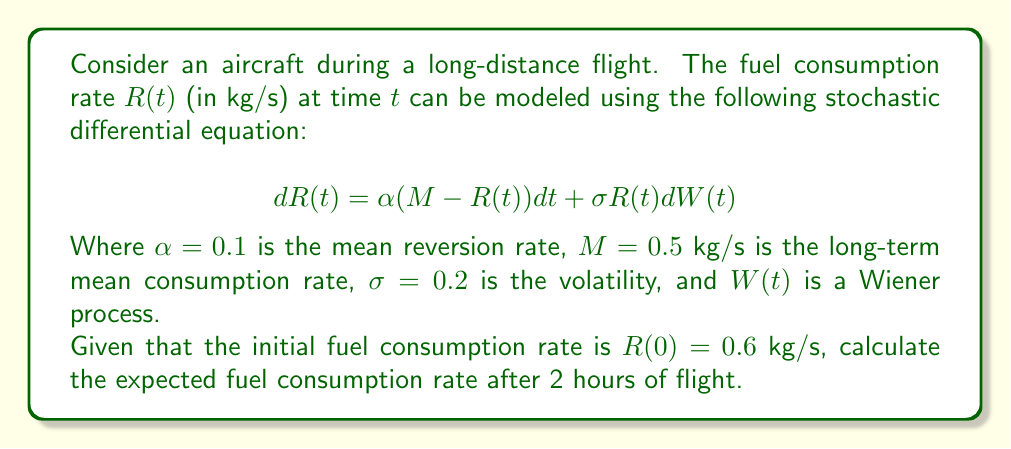Solve this math problem. To solve this problem, we need to understand the properties of the Ornstein-Uhlenbeck process, which is described by the given stochastic differential equation. The solution to this equation has the following properties:

1) The expected value of $R(t)$ is given by:

   $$E[R(t)] = M + (R(0) - M)e^{-\alpha t}$$

2) We are given:
   - $\alpha = 0.1$
   - $M = 0.5$ kg/s
   - $R(0) = 0.6$ kg/s
   - $t = 2$ hours = 7200 seconds

3) Let's substitute these values into the equation:

   $$E[R(7200)] = 0.5 + (0.6 - 0.5)e^{-0.1 * 7200}$$

4) Simplify:
   $$E[R(7200)] = 0.5 + 0.1e^{-720}$$

5) Calculate:
   $$E[R(7200)] \approx 0.5 + 0.1 * (5.2 * 10^{-313}) \approx 0.5$$ kg/s

The expected fuel consumption rate after 2 hours is approximately 0.5 kg/s, which is the long-term mean consumption rate. This makes sense because after a long time, the process tends to revert to its mean value.
Answer: 0.5 kg/s 